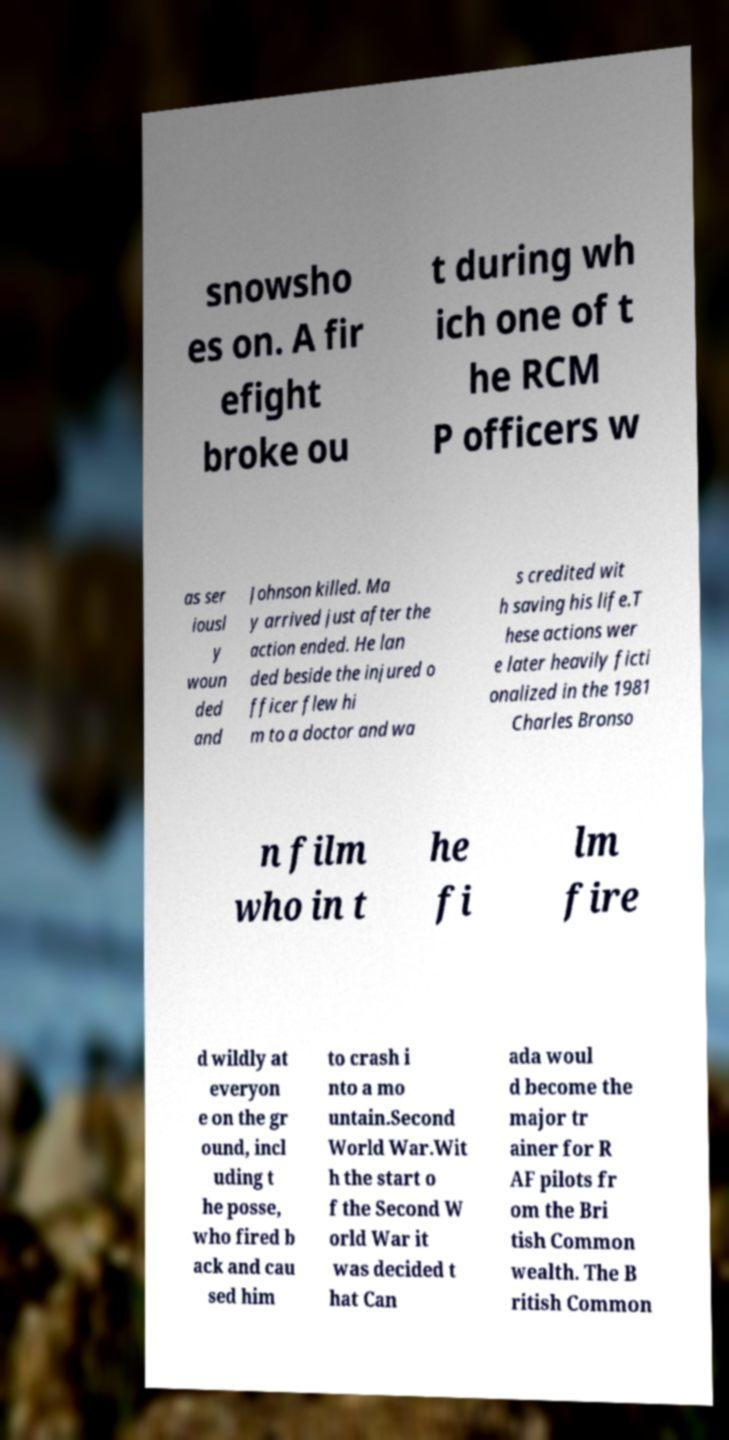For documentation purposes, I need the text within this image transcribed. Could you provide that? snowsho es on. A fir efight broke ou t during wh ich one of t he RCM P officers w as ser iousl y woun ded and Johnson killed. Ma y arrived just after the action ended. He lan ded beside the injured o fficer flew hi m to a doctor and wa s credited wit h saving his life.T hese actions wer e later heavily ficti onalized in the 1981 Charles Bronso n film who in t he fi lm fire d wildly at everyon e on the gr ound, incl uding t he posse, who fired b ack and cau sed him to crash i nto a mo untain.Second World War.Wit h the start o f the Second W orld War it was decided t hat Can ada woul d become the major tr ainer for R AF pilots fr om the Bri tish Common wealth. The B ritish Common 